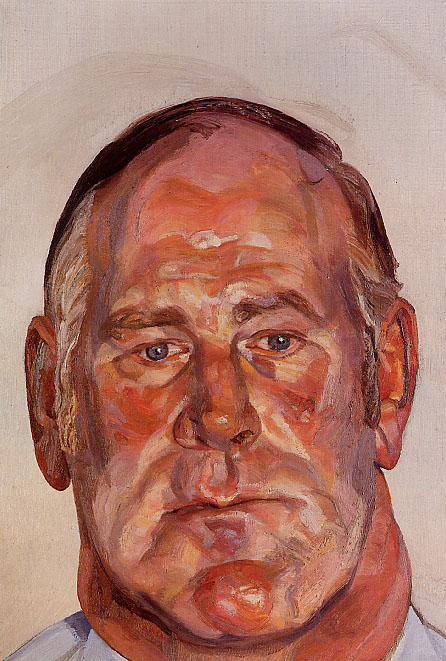How could the choice of colors affect the viewer's interpretation of this painting? The choice of bright, warm colors like orange, red, and pink directly impacts the viewer's emotional response, instilling a sense of energy and vividness. Even though the subject's expression is calm and introspective, the colors might evoke feelings of passion, intensity, or a dynamic inner life. This contrast between color and expression invites the viewer to ponder deeper about the psyche and emotional state of the portrayed individual. Does the use of such dynamic colors contrast with the calmness of the subject? Absolutely, the dynamic and warm colors create a striking contrast with the subject's serene and introspective demeanor. This juxtaposition may be interpreted as an external representation of vibrant, perhaps tumultuous, internal emotions, mirroring the complexity of human feelings where calmness and intensity coexist. 